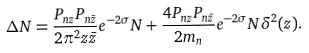<formula> <loc_0><loc_0><loc_500><loc_500>\Delta N = \frac { P _ { n z } P _ { n \bar { z } } } { 2 \pi ^ { 2 } z \bar { z } } e ^ { - 2 \sigma } N + \frac { 4 P _ { n z } P _ { n \bar { z } } } { 2 m _ { n } } e ^ { - 2 \sigma } N \delta ^ { 2 } ( z ) .</formula> 